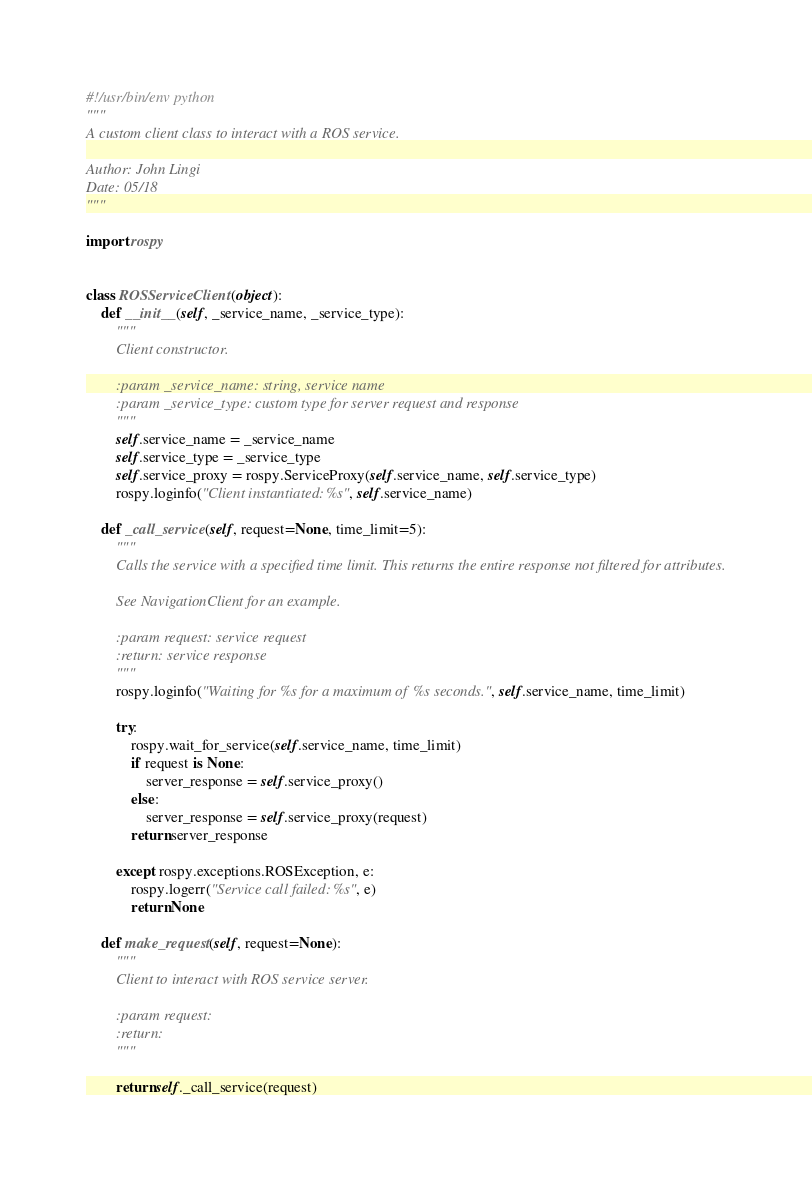Convert code to text. <code><loc_0><loc_0><loc_500><loc_500><_Python_>#!/usr/bin/env python
"""
A custom client class to interact with a ROS service.

Author: John Lingi
Date: 05/18
"""

import rospy


class ROSServiceClient(object):
    def __init__(self, _service_name, _service_type):
        """
        Client constructor.

        :param _service_name: string, service name
        :param _service_type: custom type for server request and response
        """
        self.service_name = _service_name
        self.service_type = _service_type
        self.service_proxy = rospy.ServiceProxy(self.service_name, self.service_type)
        rospy.loginfo("Client instantiated: %s", self.service_name)

    def _call_service(self, request=None, time_limit=5):
        """
        Calls the service with a specified time limit. This returns the entire response not filtered for attributes.

        See NavigationClient for an example.

        :param request: service request
        :return: service response
        """
        rospy.loginfo("Waiting for %s for a maximum of %s seconds.", self.service_name, time_limit)

        try:
            rospy.wait_for_service(self.service_name, time_limit)
            if request is None:
                server_response = self.service_proxy()
            else:
                server_response = self.service_proxy(request)
            return server_response

        except rospy.exceptions.ROSException, e:
            rospy.logerr("Service call failed: %s", e)
            return None

    def make_request(self, request=None):
        """
        Client to interact with ROS service server.

        :param request:
        :return:
        """

        return self._call_service(request)
</code> 